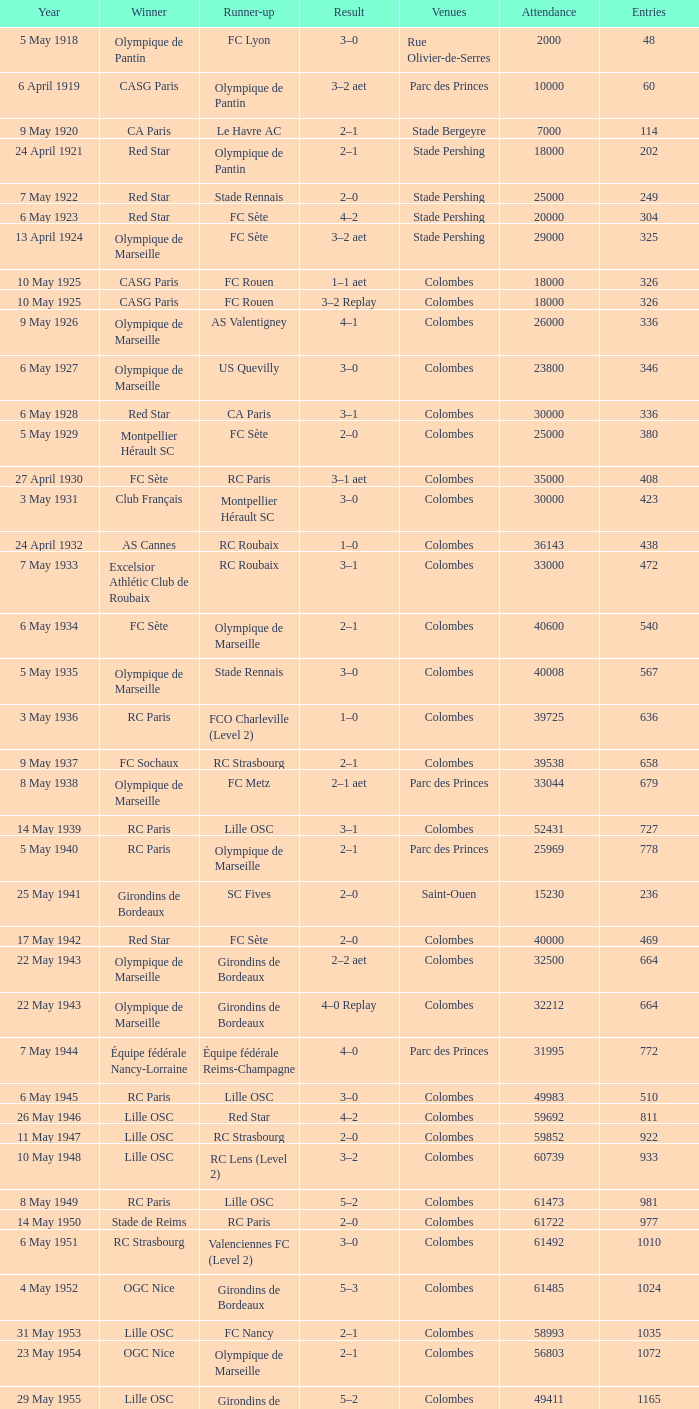How many games had red star as the runner up? 1.0. 